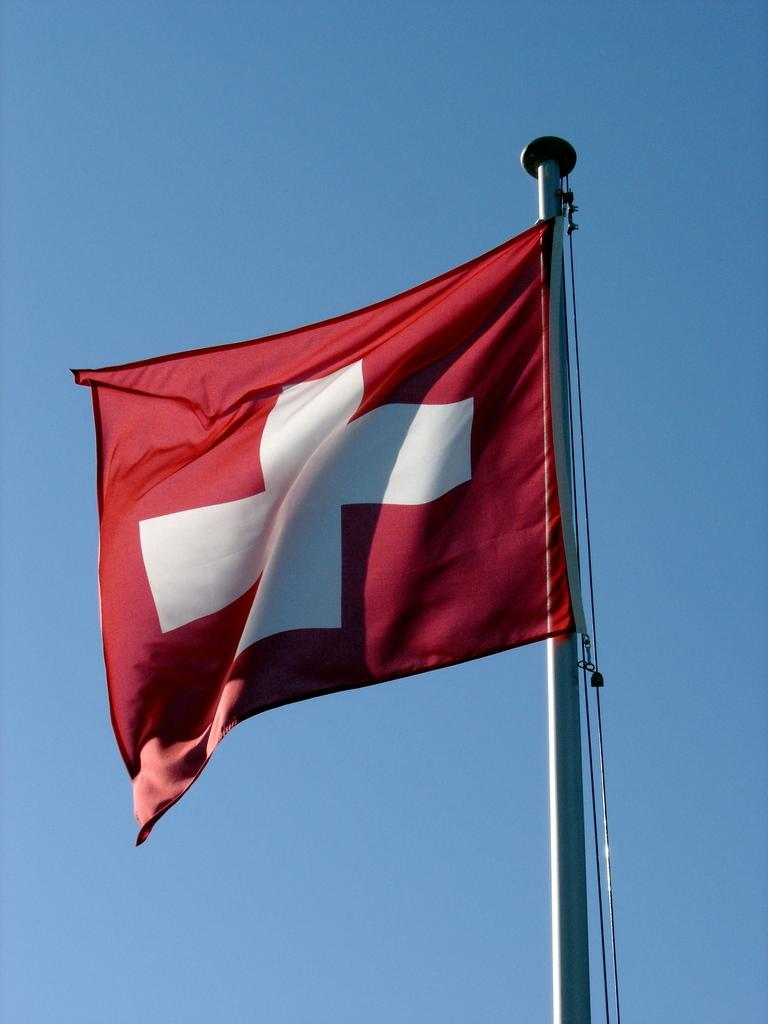What is present in the image that represents a country or organization? There is a flag in the image. How is the flag positioned in the image? The flag is flying in the air. What colors are used on the flag in the image? The flag is in red and white color. Can you see any airplanes working in the image? There is no airplane present in the image, nor is there any indication of work being done. 